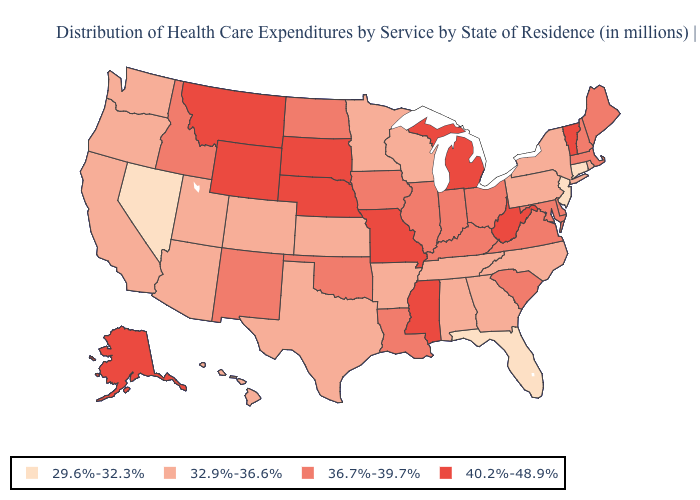Among the states that border Michigan , does Ohio have the lowest value?
Be succinct. No. What is the value of California?
Give a very brief answer. 32.9%-36.6%. What is the highest value in states that border Oregon?
Concise answer only. 36.7%-39.7%. What is the value of Missouri?
Keep it brief. 40.2%-48.9%. Does Florida have the lowest value in the South?
Short answer required. Yes. How many symbols are there in the legend?
Write a very short answer. 4. Name the states that have a value in the range 29.6%-32.3%?
Answer briefly. Connecticut, Florida, Nevada, New Jersey. Name the states that have a value in the range 29.6%-32.3%?
Give a very brief answer. Connecticut, Florida, Nevada, New Jersey. Among the states that border New Jersey , which have the highest value?
Keep it brief. Delaware. Does Idaho have a higher value than Colorado?
Short answer required. Yes. What is the value of Tennessee?
Keep it brief. 32.9%-36.6%. How many symbols are there in the legend?
Concise answer only. 4. What is the value of Oklahoma?
Concise answer only. 36.7%-39.7%. Does the map have missing data?
Be succinct. No. What is the value of Rhode Island?
Short answer required. 32.9%-36.6%. 